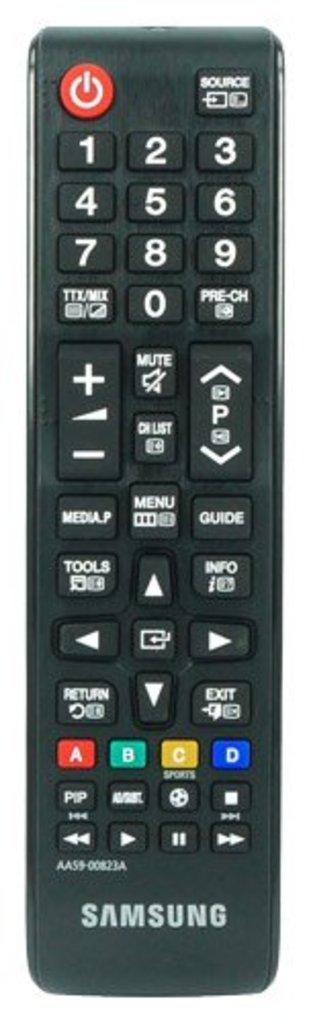<image>
Create a compact narrative representing the image presented. A black Samsung remote control with a red power button in the to left corner. 